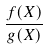<formula> <loc_0><loc_0><loc_500><loc_500>\frac { f ( X ) } { g ( X ) }</formula> 